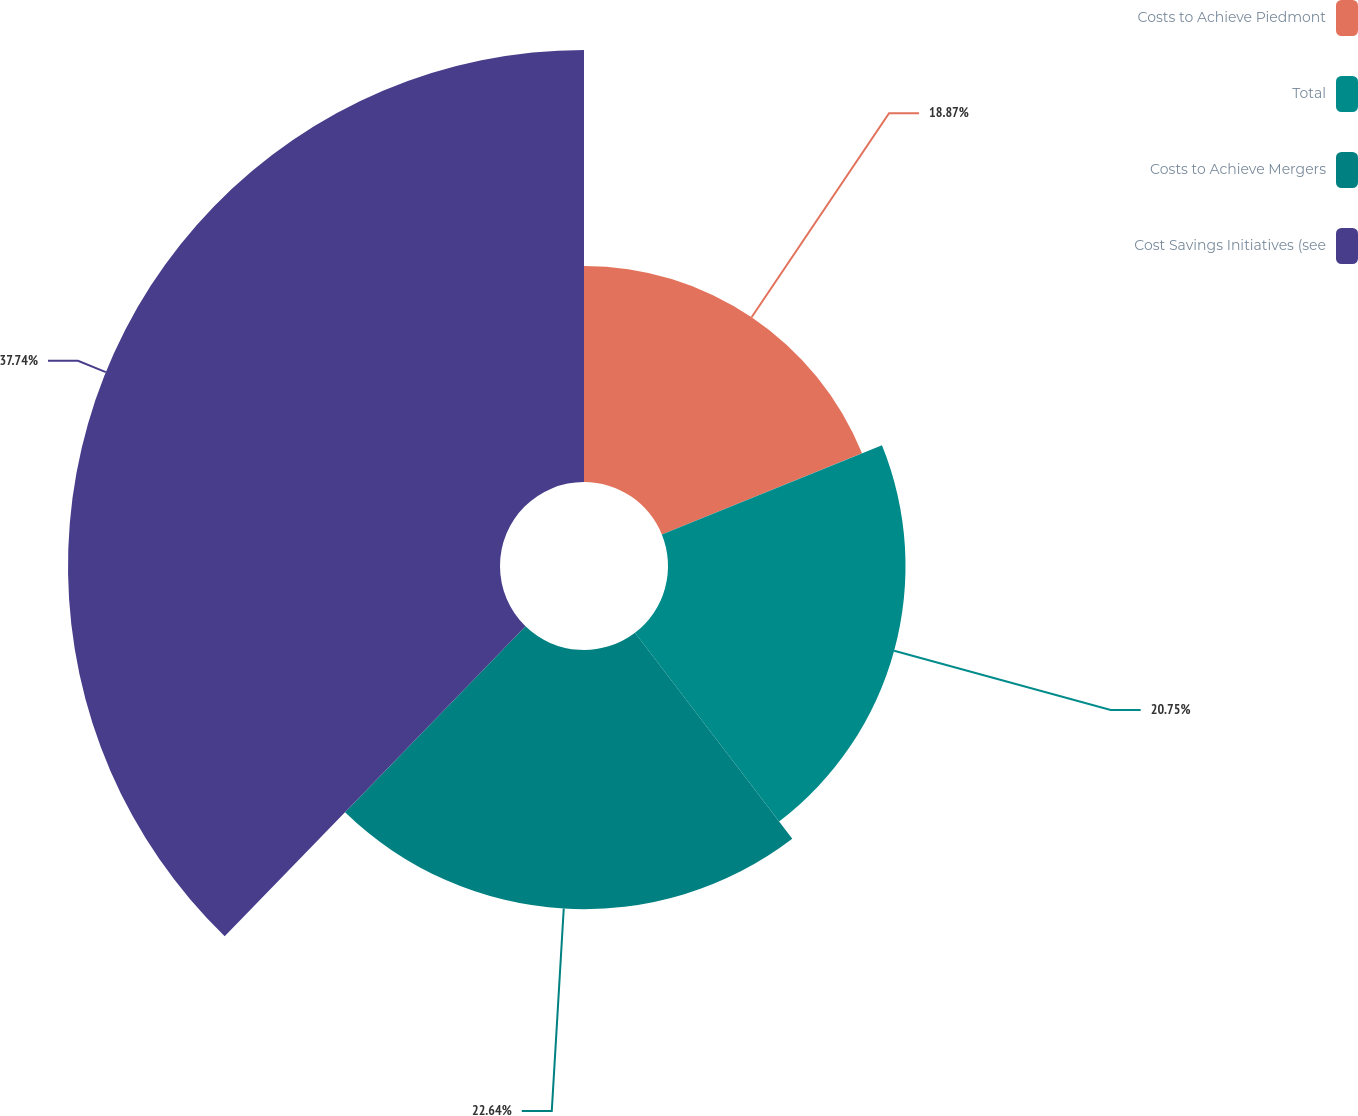Convert chart. <chart><loc_0><loc_0><loc_500><loc_500><pie_chart><fcel>Costs to Achieve Piedmont<fcel>Total<fcel>Costs to Achieve Mergers<fcel>Cost Savings Initiatives (see<nl><fcel>18.87%<fcel>20.75%<fcel>22.64%<fcel>37.74%<nl></chart> 